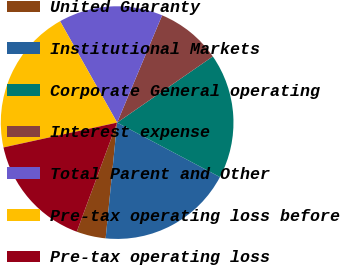Convert chart. <chart><loc_0><loc_0><loc_500><loc_500><pie_chart><fcel>United Guaranty<fcel>Institutional Markets<fcel>Corporate General operating<fcel>Interest expense<fcel>Total Parent and Other<fcel>Pre-tax operating loss before<fcel>Pre-tax operating loss<nl><fcel>4.07%<fcel>18.82%<fcel>17.38%<fcel>9.05%<fcel>14.48%<fcel>20.27%<fcel>15.93%<nl></chart> 